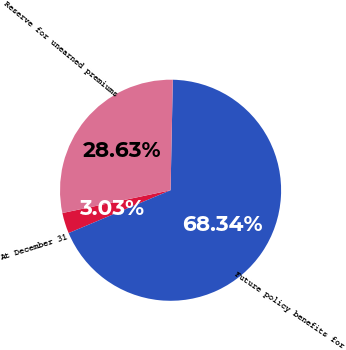Convert chart. <chart><loc_0><loc_0><loc_500><loc_500><pie_chart><fcel>At December 31<fcel>Future policy benefits for<fcel>Reserve for unearned premiums<nl><fcel>3.03%<fcel>68.34%<fcel>28.63%<nl></chart> 